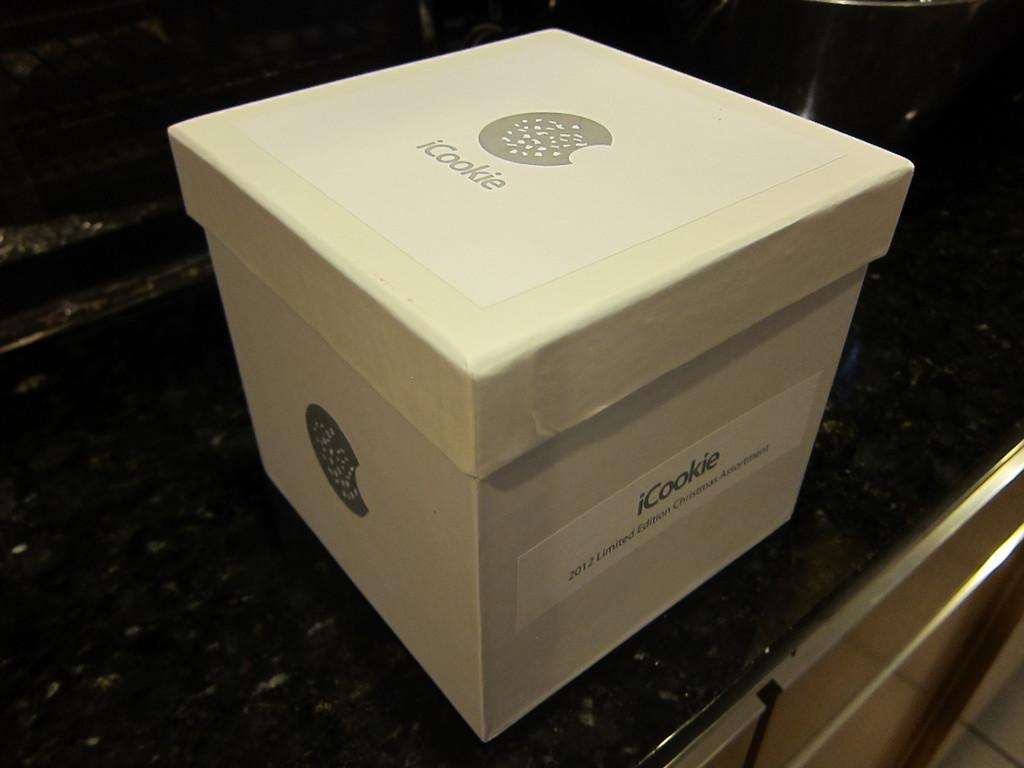<image>
Describe the image concisely. A white cardboard box from the company iCookie. 